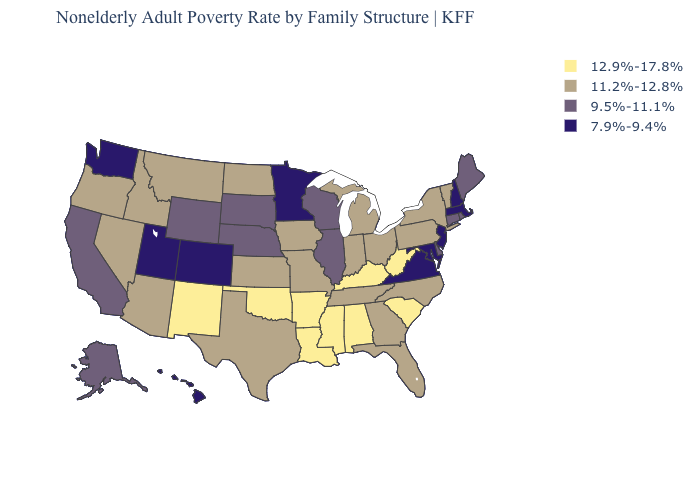Name the states that have a value in the range 11.2%-12.8%?
Short answer required. Arizona, Florida, Georgia, Idaho, Indiana, Iowa, Kansas, Michigan, Missouri, Montana, Nevada, New York, North Carolina, North Dakota, Ohio, Oregon, Pennsylvania, Tennessee, Texas, Vermont. Does the first symbol in the legend represent the smallest category?
Be succinct. No. How many symbols are there in the legend?
Give a very brief answer. 4. Among the states that border North Dakota , does Minnesota have the lowest value?
Give a very brief answer. Yes. What is the value of Minnesota?
Keep it brief. 7.9%-9.4%. What is the value of Iowa?
Give a very brief answer. 11.2%-12.8%. Among the states that border Illinois , does Kentucky have the highest value?
Short answer required. Yes. Name the states that have a value in the range 9.5%-11.1%?
Write a very short answer. Alaska, California, Connecticut, Delaware, Illinois, Maine, Nebraska, Rhode Island, South Dakota, Wisconsin, Wyoming. Name the states that have a value in the range 7.9%-9.4%?
Short answer required. Colorado, Hawaii, Maryland, Massachusetts, Minnesota, New Hampshire, New Jersey, Utah, Virginia, Washington. Does Maryland have the lowest value in the USA?
Be succinct. Yes. Does Louisiana have the highest value in the South?
Give a very brief answer. Yes. Name the states that have a value in the range 9.5%-11.1%?
Short answer required. Alaska, California, Connecticut, Delaware, Illinois, Maine, Nebraska, Rhode Island, South Dakota, Wisconsin, Wyoming. What is the value of Texas?
Short answer required. 11.2%-12.8%. Among the states that border Tennessee , does Virginia have the lowest value?
Write a very short answer. Yes. Does Illinois have the highest value in the MidWest?
Give a very brief answer. No. 